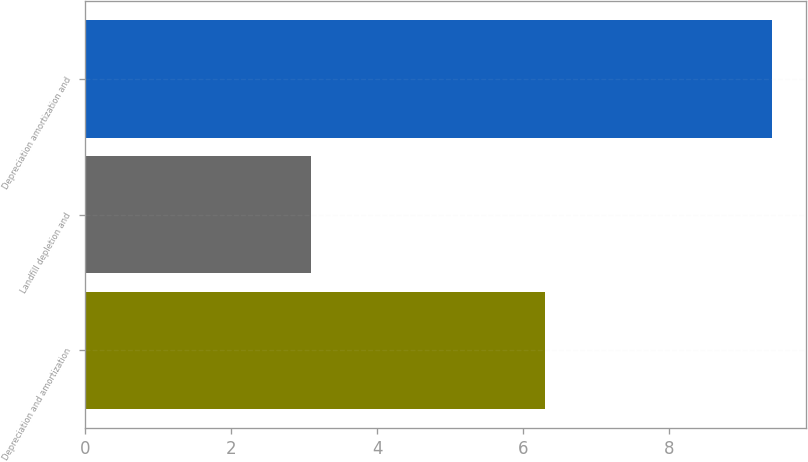Convert chart. <chart><loc_0><loc_0><loc_500><loc_500><bar_chart><fcel>Depreciation and amortization<fcel>Landfill depletion and<fcel>Depreciation amortization and<nl><fcel>6.3<fcel>3.1<fcel>9.4<nl></chart> 